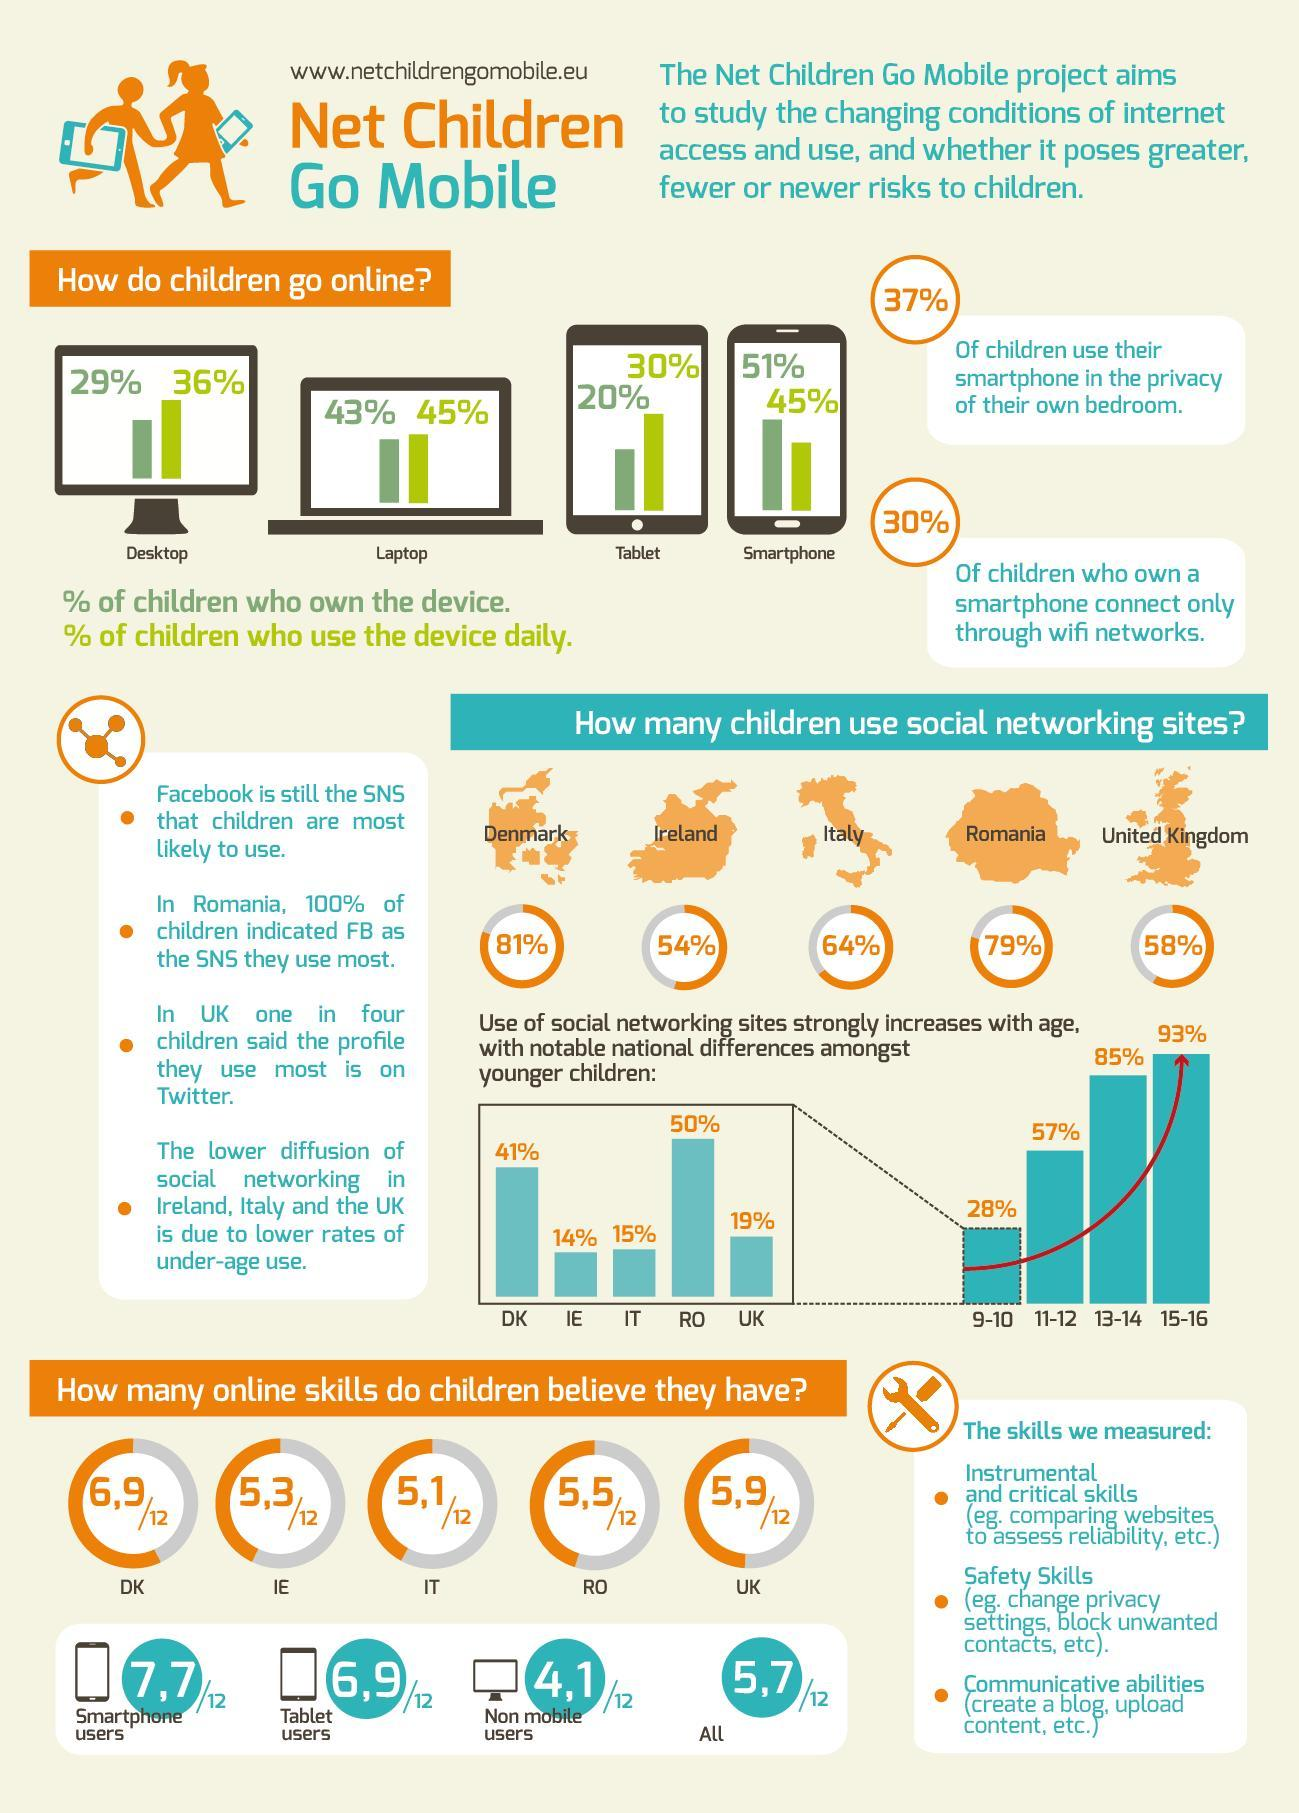Which age group in children comes in second for their use of social networking sites?
Answer the question with a short phrase. 13-14 Percentage of Children from which country use social networking sites the most? Denmark Which country comes in second in Percentage of Children who use social networking sites the most? Romania What is increase in usage of social networking sites in children directly proportional to? increase in age 